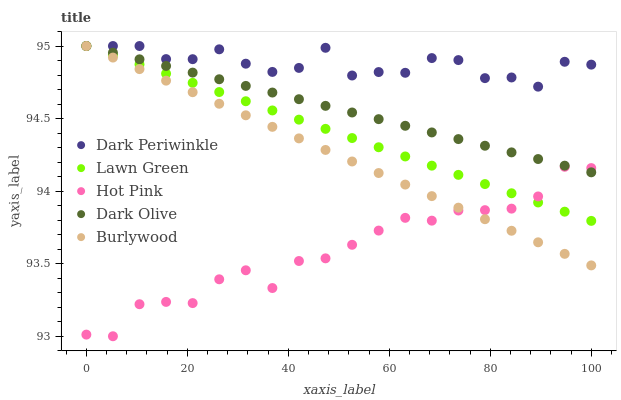Does Hot Pink have the minimum area under the curve?
Answer yes or no. Yes. Does Dark Periwinkle have the maximum area under the curve?
Answer yes or no. Yes. Does Lawn Green have the minimum area under the curve?
Answer yes or no. No. Does Lawn Green have the maximum area under the curve?
Answer yes or no. No. Is Burlywood the smoothest?
Answer yes or no. Yes. Is Dark Periwinkle the roughest?
Answer yes or no. Yes. Is Lawn Green the smoothest?
Answer yes or no. No. Is Lawn Green the roughest?
Answer yes or no. No. Does Hot Pink have the lowest value?
Answer yes or no. Yes. Does Lawn Green have the lowest value?
Answer yes or no. No. Does Burlywood have the highest value?
Answer yes or no. Yes. Does Hot Pink have the highest value?
Answer yes or no. No. Is Hot Pink less than Dark Periwinkle?
Answer yes or no. Yes. Is Dark Periwinkle greater than Hot Pink?
Answer yes or no. Yes. Does Dark Olive intersect Lawn Green?
Answer yes or no. Yes. Is Dark Olive less than Lawn Green?
Answer yes or no. No. Is Dark Olive greater than Lawn Green?
Answer yes or no. No. Does Hot Pink intersect Dark Periwinkle?
Answer yes or no. No. 